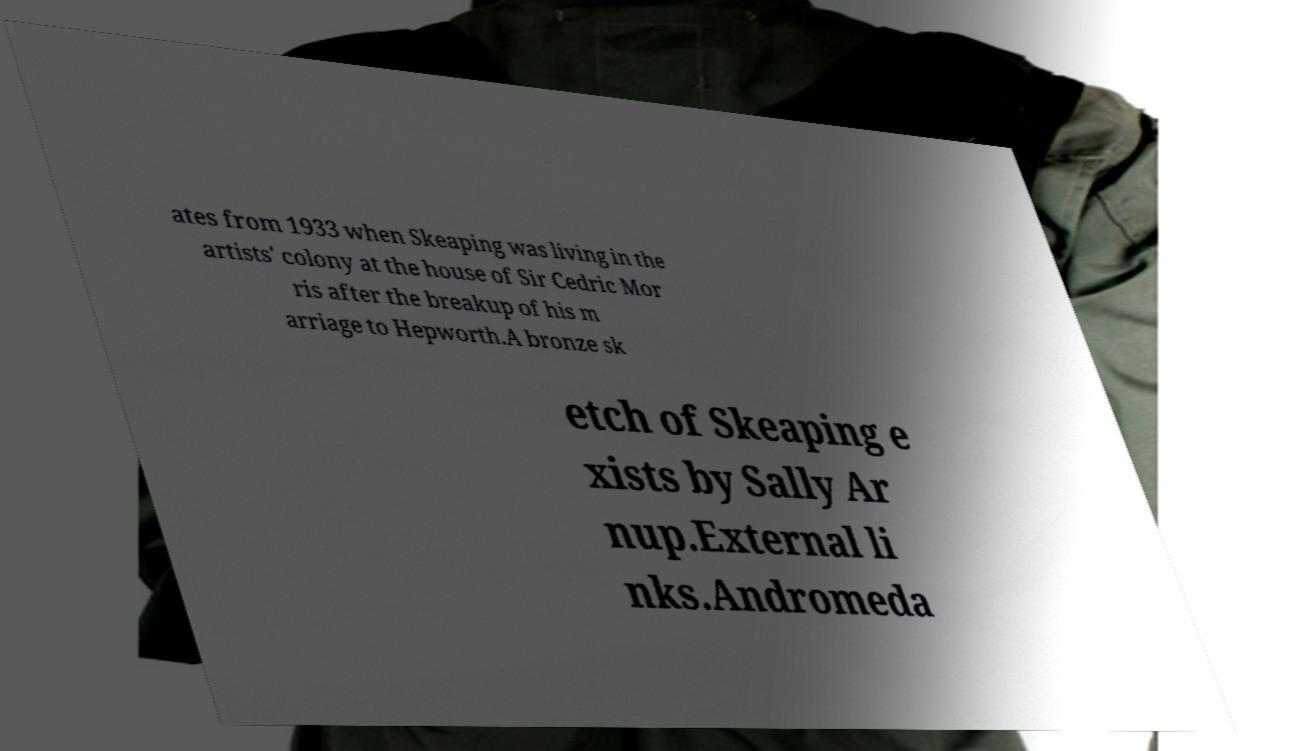Could you extract and type out the text from this image? ates from 1933 when Skeaping was living in the artists' colony at the house of Sir Cedric Mor ris after the breakup of his m arriage to Hepworth.A bronze sk etch of Skeaping e xists by Sally Ar nup.External li nks.Andromeda 